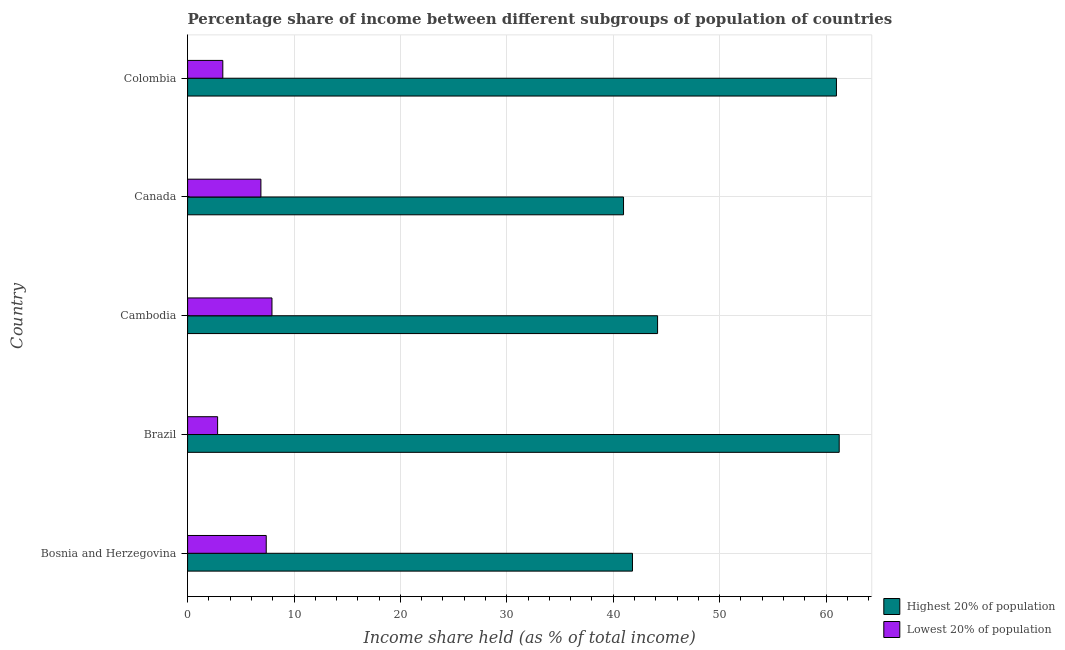How many different coloured bars are there?
Your answer should be compact. 2. How many groups of bars are there?
Provide a succinct answer. 5. Are the number of bars on each tick of the Y-axis equal?
Keep it short and to the point. Yes. How many bars are there on the 4th tick from the top?
Offer a very short reply. 2. What is the label of the 1st group of bars from the top?
Your answer should be very brief. Colombia. What is the income share held by lowest 20% of the population in Colombia?
Provide a short and direct response. 3.31. Across all countries, what is the maximum income share held by highest 20% of the population?
Ensure brevity in your answer.  61.24. Across all countries, what is the minimum income share held by highest 20% of the population?
Provide a succinct answer. 40.97. What is the total income share held by lowest 20% of the population in the graph?
Provide a succinct answer. 28.34. What is the difference between the income share held by highest 20% of the population in Bosnia and Herzegovina and that in Canada?
Provide a succinct answer. 0.84. What is the difference between the income share held by lowest 20% of the population in Canada and the income share held by highest 20% of the population in Cambodia?
Offer a very short reply. -37.28. What is the average income share held by highest 20% of the population per country?
Make the answer very short. 49.83. What is the difference between the income share held by highest 20% of the population and income share held by lowest 20% of the population in Colombia?
Keep it short and to the point. 57.67. In how many countries, is the income share held by highest 20% of the population greater than 22 %?
Offer a very short reply. 5. What is the ratio of the income share held by highest 20% of the population in Bosnia and Herzegovina to that in Brazil?
Provide a succinct answer. 0.68. What is the difference between the highest and the second highest income share held by highest 20% of the population?
Give a very brief answer. 0.26. What is the difference between the highest and the lowest income share held by lowest 20% of the population?
Your answer should be compact. 5.11. Is the sum of the income share held by highest 20% of the population in Cambodia and Canada greater than the maximum income share held by lowest 20% of the population across all countries?
Give a very brief answer. Yes. What does the 1st bar from the top in Canada represents?
Keep it short and to the point. Lowest 20% of population. What does the 1st bar from the bottom in Cambodia represents?
Provide a short and direct response. Highest 20% of population. How many bars are there?
Your answer should be compact. 10. Are all the bars in the graph horizontal?
Offer a very short reply. Yes. How many countries are there in the graph?
Your response must be concise. 5. What is the difference between two consecutive major ticks on the X-axis?
Give a very brief answer. 10. Does the graph contain any zero values?
Provide a succinct answer. No. Does the graph contain grids?
Your answer should be compact. Yes. Where does the legend appear in the graph?
Your response must be concise. Bottom right. What is the title of the graph?
Your answer should be very brief. Percentage share of income between different subgroups of population of countries. Does "Fraud firms" appear as one of the legend labels in the graph?
Offer a very short reply. No. What is the label or title of the X-axis?
Your response must be concise. Income share held (as % of total income). What is the label or title of the Y-axis?
Make the answer very short. Country. What is the Income share held (as % of total income) in Highest 20% of population in Bosnia and Herzegovina?
Your answer should be very brief. 41.81. What is the Income share held (as % of total income) in Lowest 20% of population in Bosnia and Herzegovina?
Ensure brevity in your answer.  7.39. What is the Income share held (as % of total income) of Highest 20% of population in Brazil?
Offer a terse response. 61.24. What is the Income share held (as % of total income) of Lowest 20% of population in Brazil?
Make the answer very short. 2.82. What is the Income share held (as % of total income) of Highest 20% of population in Cambodia?
Your response must be concise. 44.17. What is the Income share held (as % of total income) of Lowest 20% of population in Cambodia?
Provide a short and direct response. 7.93. What is the Income share held (as % of total income) of Highest 20% of population in Canada?
Give a very brief answer. 40.97. What is the Income share held (as % of total income) of Lowest 20% of population in Canada?
Provide a succinct answer. 6.89. What is the Income share held (as % of total income) of Highest 20% of population in Colombia?
Make the answer very short. 60.98. What is the Income share held (as % of total income) of Lowest 20% of population in Colombia?
Make the answer very short. 3.31. Across all countries, what is the maximum Income share held (as % of total income) in Highest 20% of population?
Make the answer very short. 61.24. Across all countries, what is the maximum Income share held (as % of total income) in Lowest 20% of population?
Make the answer very short. 7.93. Across all countries, what is the minimum Income share held (as % of total income) in Highest 20% of population?
Keep it short and to the point. 40.97. Across all countries, what is the minimum Income share held (as % of total income) in Lowest 20% of population?
Your answer should be compact. 2.82. What is the total Income share held (as % of total income) in Highest 20% of population in the graph?
Give a very brief answer. 249.17. What is the total Income share held (as % of total income) in Lowest 20% of population in the graph?
Give a very brief answer. 28.34. What is the difference between the Income share held (as % of total income) in Highest 20% of population in Bosnia and Herzegovina and that in Brazil?
Ensure brevity in your answer.  -19.43. What is the difference between the Income share held (as % of total income) in Lowest 20% of population in Bosnia and Herzegovina and that in Brazil?
Offer a terse response. 4.57. What is the difference between the Income share held (as % of total income) in Highest 20% of population in Bosnia and Herzegovina and that in Cambodia?
Offer a very short reply. -2.36. What is the difference between the Income share held (as % of total income) in Lowest 20% of population in Bosnia and Herzegovina and that in Cambodia?
Ensure brevity in your answer.  -0.54. What is the difference between the Income share held (as % of total income) of Highest 20% of population in Bosnia and Herzegovina and that in Canada?
Provide a short and direct response. 0.84. What is the difference between the Income share held (as % of total income) of Highest 20% of population in Bosnia and Herzegovina and that in Colombia?
Provide a succinct answer. -19.17. What is the difference between the Income share held (as % of total income) of Lowest 20% of population in Bosnia and Herzegovina and that in Colombia?
Keep it short and to the point. 4.08. What is the difference between the Income share held (as % of total income) in Highest 20% of population in Brazil and that in Cambodia?
Offer a very short reply. 17.07. What is the difference between the Income share held (as % of total income) in Lowest 20% of population in Brazil and that in Cambodia?
Provide a succinct answer. -5.11. What is the difference between the Income share held (as % of total income) of Highest 20% of population in Brazil and that in Canada?
Offer a terse response. 20.27. What is the difference between the Income share held (as % of total income) in Lowest 20% of population in Brazil and that in Canada?
Your answer should be very brief. -4.07. What is the difference between the Income share held (as % of total income) in Highest 20% of population in Brazil and that in Colombia?
Offer a terse response. 0.26. What is the difference between the Income share held (as % of total income) of Lowest 20% of population in Brazil and that in Colombia?
Give a very brief answer. -0.49. What is the difference between the Income share held (as % of total income) in Highest 20% of population in Cambodia and that in Canada?
Your response must be concise. 3.2. What is the difference between the Income share held (as % of total income) in Highest 20% of population in Cambodia and that in Colombia?
Keep it short and to the point. -16.81. What is the difference between the Income share held (as % of total income) in Lowest 20% of population in Cambodia and that in Colombia?
Provide a short and direct response. 4.62. What is the difference between the Income share held (as % of total income) in Highest 20% of population in Canada and that in Colombia?
Give a very brief answer. -20.01. What is the difference between the Income share held (as % of total income) in Lowest 20% of population in Canada and that in Colombia?
Offer a very short reply. 3.58. What is the difference between the Income share held (as % of total income) of Highest 20% of population in Bosnia and Herzegovina and the Income share held (as % of total income) of Lowest 20% of population in Brazil?
Provide a succinct answer. 38.99. What is the difference between the Income share held (as % of total income) in Highest 20% of population in Bosnia and Herzegovina and the Income share held (as % of total income) in Lowest 20% of population in Cambodia?
Make the answer very short. 33.88. What is the difference between the Income share held (as % of total income) in Highest 20% of population in Bosnia and Herzegovina and the Income share held (as % of total income) in Lowest 20% of population in Canada?
Provide a succinct answer. 34.92. What is the difference between the Income share held (as % of total income) of Highest 20% of population in Bosnia and Herzegovina and the Income share held (as % of total income) of Lowest 20% of population in Colombia?
Ensure brevity in your answer.  38.5. What is the difference between the Income share held (as % of total income) of Highest 20% of population in Brazil and the Income share held (as % of total income) of Lowest 20% of population in Cambodia?
Your answer should be very brief. 53.31. What is the difference between the Income share held (as % of total income) in Highest 20% of population in Brazil and the Income share held (as % of total income) in Lowest 20% of population in Canada?
Make the answer very short. 54.35. What is the difference between the Income share held (as % of total income) of Highest 20% of population in Brazil and the Income share held (as % of total income) of Lowest 20% of population in Colombia?
Offer a terse response. 57.93. What is the difference between the Income share held (as % of total income) of Highest 20% of population in Cambodia and the Income share held (as % of total income) of Lowest 20% of population in Canada?
Your answer should be very brief. 37.28. What is the difference between the Income share held (as % of total income) in Highest 20% of population in Cambodia and the Income share held (as % of total income) in Lowest 20% of population in Colombia?
Offer a very short reply. 40.86. What is the difference between the Income share held (as % of total income) of Highest 20% of population in Canada and the Income share held (as % of total income) of Lowest 20% of population in Colombia?
Provide a short and direct response. 37.66. What is the average Income share held (as % of total income) in Highest 20% of population per country?
Make the answer very short. 49.83. What is the average Income share held (as % of total income) in Lowest 20% of population per country?
Make the answer very short. 5.67. What is the difference between the Income share held (as % of total income) of Highest 20% of population and Income share held (as % of total income) of Lowest 20% of population in Bosnia and Herzegovina?
Ensure brevity in your answer.  34.42. What is the difference between the Income share held (as % of total income) in Highest 20% of population and Income share held (as % of total income) in Lowest 20% of population in Brazil?
Your answer should be very brief. 58.42. What is the difference between the Income share held (as % of total income) in Highest 20% of population and Income share held (as % of total income) in Lowest 20% of population in Cambodia?
Ensure brevity in your answer.  36.24. What is the difference between the Income share held (as % of total income) of Highest 20% of population and Income share held (as % of total income) of Lowest 20% of population in Canada?
Provide a succinct answer. 34.08. What is the difference between the Income share held (as % of total income) of Highest 20% of population and Income share held (as % of total income) of Lowest 20% of population in Colombia?
Make the answer very short. 57.67. What is the ratio of the Income share held (as % of total income) in Highest 20% of population in Bosnia and Herzegovina to that in Brazil?
Make the answer very short. 0.68. What is the ratio of the Income share held (as % of total income) in Lowest 20% of population in Bosnia and Herzegovina to that in Brazil?
Your answer should be compact. 2.62. What is the ratio of the Income share held (as % of total income) in Highest 20% of population in Bosnia and Herzegovina to that in Cambodia?
Keep it short and to the point. 0.95. What is the ratio of the Income share held (as % of total income) of Lowest 20% of population in Bosnia and Herzegovina to that in Cambodia?
Offer a terse response. 0.93. What is the ratio of the Income share held (as % of total income) in Highest 20% of population in Bosnia and Herzegovina to that in Canada?
Your answer should be very brief. 1.02. What is the ratio of the Income share held (as % of total income) in Lowest 20% of population in Bosnia and Herzegovina to that in Canada?
Give a very brief answer. 1.07. What is the ratio of the Income share held (as % of total income) of Highest 20% of population in Bosnia and Herzegovina to that in Colombia?
Provide a short and direct response. 0.69. What is the ratio of the Income share held (as % of total income) in Lowest 20% of population in Bosnia and Herzegovina to that in Colombia?
Provide a short and direct response. 2.23. What is the ratio of the Income share held (as % of total income) of Highest 20% of population in Brazil to that in Cambodia?
Make the answer very short. 1.39. What is the ratio of the Income share held (as % of total income) in Lowest 20% of population in Brazil to that in Cambodia?
Provide a short and direct response. 0.36. What is the ratio of the Income share held (as % of total income) in Highest 20% of population in Brazil to that in Canada?
Offer a terse response. 1.49. What is the ratio of the Income share held (as % of total income) in Lowest 20% of population in Brazil to that in Canada?
Your answer should be compact. 0.41. What is the ratio of the Income share held (as % of total income) in Lowest 20% of population in Brazil to that in Colombia?
Keep it short and to the point. 0.85. What is the ratio of the Income share held (as % of total income) in Highest 20% of population in Cambodia to that in Canada?
Keep it short and to the point. 1.08. What is the ratio of the Income share held (as % of total income) of Lowest 20% of population in Cambodia to that in Canada?
Make the answer very short. 1.15. What is the ratio of the Income share held (as % of total income) in Highest 20% of population in Cambodia to that in Colombia?
Offer a very short reply. 0.72. What is the ratio of the Income share held (as % of total income) of Lowest 20% of population in Cambodia to that in Colombia?
Provide a succinct answer. 2.4. What is the ratio of the Income share held (as % of total income) of Highest 20% of population in Canada to that in Colombia?
Offer a very short reply. 0.67. What is the ratio of the Income share held (as % of total income) in Lowest 20% of population in Canada to that in Colombia?
Keep it short and to the point. 2.08. What is the difference between the highest and the second highest Income share held (as % of total income) of Highest 20% of population?
Your answer should be very brief. 0.26. What is the difference between the highest and the second highest Income share held (as % of total income) of Lowest 20% of population?
Your response must be concise. 0.54. What is the difference between the highest and the lowest Income share held (as % of total income) in Highest 20% of population?
Offer a terse response. 20.27. What is the difference between the highest and the lowest Income share held (as % of total income) in Lowest 20% of population?
Provide a short and direct response. 5.11. 